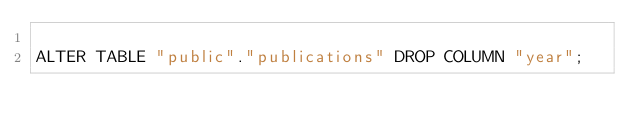Convert code to text. <code><loc_0><loc_0><loc_500><loc_500><_SQL_>
ALTER TABLE "public"."publications" DROP COLUMN "year";</code> 